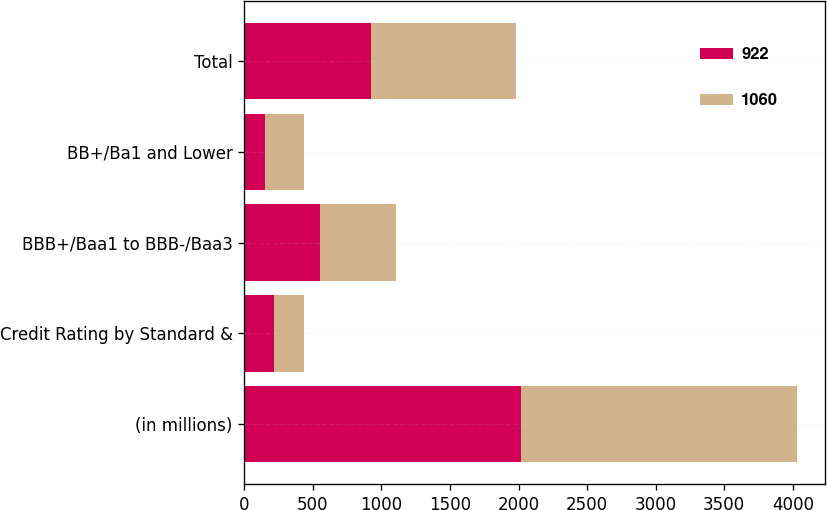<chart> <loc_0><loc_0><loc_500><loc_500><stacked_bar_chart><ecel><fcel>(in millions)<fcel>Credit Rating by Standard &<fcel>BBB+/Baa1 to BBB-/Baa3<fcel>BB+/Ba1 and Lower<fcel>Total<nl><fcel>922<fcel>2017<fcel>220<fcel>550<fcel>152<fcel>922<nl><fcel>1060<fcel>2016<fcel>218<fcel>559<fcel>283<fcel>1060<nl></chart> 